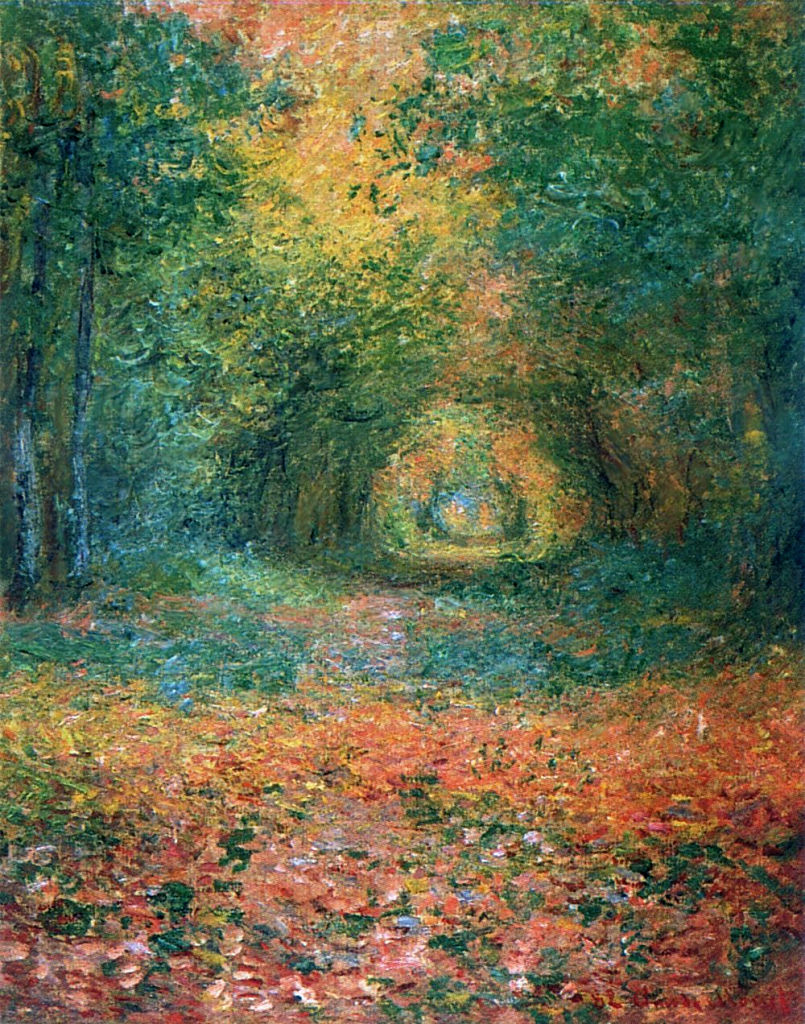Write a detailed description of the given image. This image is an exquisite example of Impressionist art, depicting a serene woodland scene. As you view the path covered with a vibrant carpet of autumn leaves, the trail seems to gracefully wind deeper into the lush, dense forest. The forest itself is alive with a diverse palette, primarily emerald greens and radiant oranges, with speckles of blue and yellow suggesting sunlight filtering through the canopy. The artist utilizes loose, almost vivacious brushstrokes typical of Impressionism to imbue the scene with dynamic movement and an almost palpable atmosphere. This painting not only showcases the tranquil beauty often sought in nature but also reflects the artist’s personal, emotional response to the landscape. 